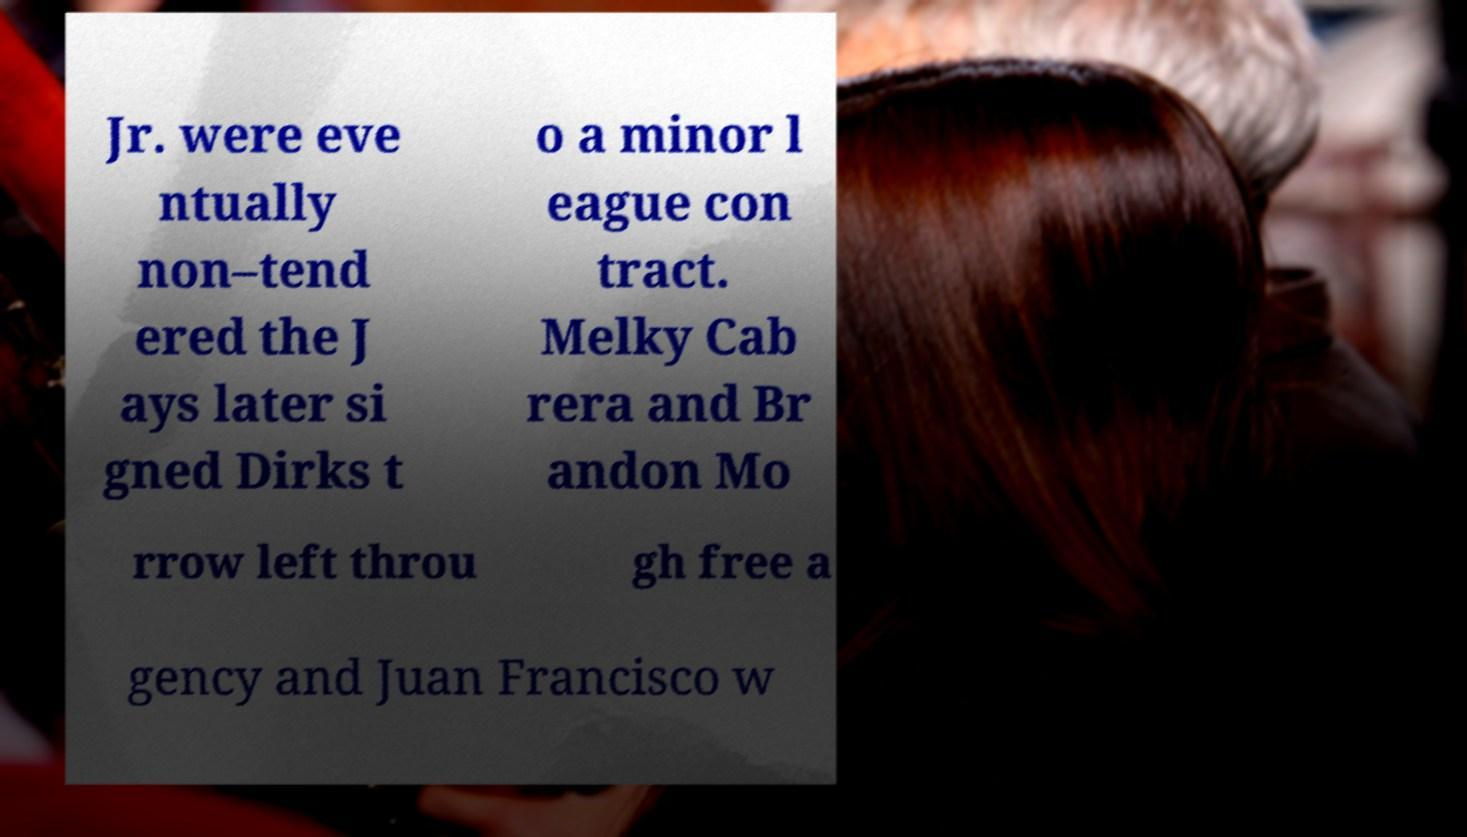I need the written content from this picture converted into text. Can you do that? Jr. were eve ntually non–tend ered the J ays later si gned Dirks t o a minor l eague con tract. Melky Cab rera and Br andon Mo rrow left throu gh free a gency and Juan Francisco w 